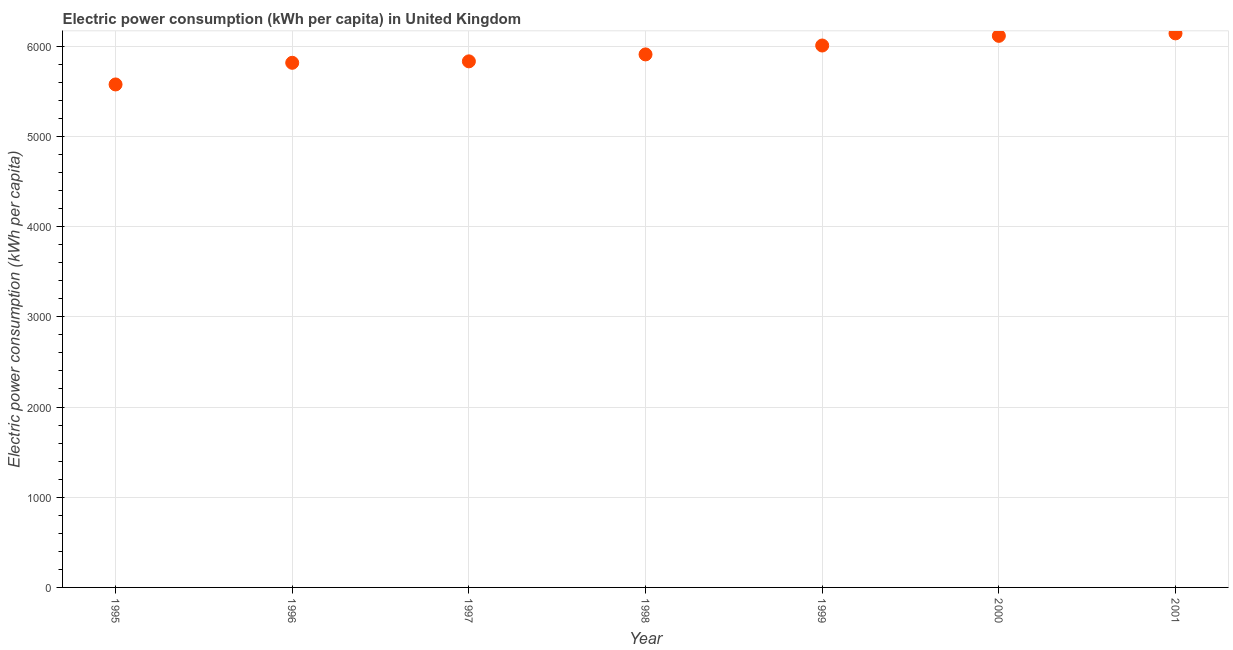What is the electric power consumption in 1996?
Keep it short and to the point. 5815.83. Across all years, what is the maximum electric power consumption?
Offer a terse response. 6141.98. Across all years, what is the minimum electric power consumption?
Provide a short and direct response. 5575.81. In which year was the electric power consumption minimum?
Give a very brief answer. 1995. What is the sum of the electric power consumption?
Your answer should be very brief. 4.14e+04. What is the difference between the electric power consumption in 1999 and 2001?
Make the answer very short. -134.5. What is the average electric power consumption per year?
Give a very brief answer. 5913.78. What is the median electric power consumption?
Give a very brief answer. 5908.87. Do a majority of the years between 2001 and 1996 (inclusive) have electric power consumption greater than 400 kWh per capita?
Provide a succinct answer. Yes. What is the ratio of the electric power consumption in 1995 to that in 2000?
Give a very brief answer. 0.91. Is the electric power consumption in 1996 less than that in 2000?
Your answer should be very brief. Yes. What is the difference between the highest and the second highest electric power consumption?
Offer a very short reply. 27.45. Is the sum of the electric power consumption in 1996 and 1999 greater than the maximum electric power consumption across all years?
Ensure brevity in your answer.  Yes. What is the difference between the highest and the lowest electric power consumption?
Your answer should be very brief. 566.17. What is the difference between two consecutive major ticks on the Y-axis?
Offer a very short reply. 1000. What is the title of the graph?
Keep it short and to the point. Electric power consumption (kWh per capita) in United Kingdom. What is the label or title of the X-axis?
Provide a short and direct response. Year. What is the label or title of the Y-axis?
Offer a terse response. Electric power consumption (kWh per capita). What is the Electric power consumption (kWh per capita) in 1995?
Your answer should be compact. 5575.81. What is the Electric power consumption (kWh per capita) in 1996?
Your answer should be compact. 5815.83. What is the Electric power consumption (kWh per capita) in 1997?
Provide a short and direct response. 5831.96. What is the Electric power consumption (kWh per capita) in 1998?
Your response must be concise. 5908.87. What is the Electric power consumption (kWh per capita) in 1999?
Your answer should be compact. 6007.48. What is the Electric power consumption (kWh per capita) in 2000?
Provide a short and direct response. 6114.53. What is the Electric power consumption (kWh per capita) in 2001?
Your answer should be very brief. 6141.98. What is the difference between the Electric power consumption (kWh per capita) in 1995 and 1996?
Offer a very short reply. -240.02. What is the difference between the Electric power consumption (kWh per capita) in 1995 and 1997?
Your response must be concise. -256.15. What is the difference between the Electric power consumption (kWh per capita) in 1995 and 1998?
Give a very brief answer. -333.06. What is the difference between the Electric power consumption (kWh per capita) in 1995 and 1999?
Make the answer very short. -431.68. What is the difference between the Electric power consumption (kWh per capita) in 1995 and 2000?
Provide a short and direct response. -538.72. What is the difference between the Electric power consumption (kWh per capita) in 1995 and 2001?
Make the answer very short. -566.17. What is the difference between the Electric power consumption (kWh per capita) in 1996 and 1997?
Your response must be concise. -16.13. What is the difference between the Electric power consumption (kWh per capita) in 1996 and 1998?
Keep it short and to the point. -93.04. What is the difference between the Electric power consumption (kWh per capita) in 1996 and 1999?
Ensure brevity in your answer.  -191.66. What is the difference between the Electric power consumption (kWh per capita) in 1996 and 2000?
Give a very brief answer. -298.7. What is the difference between the Electric power consumption (kWh per capita) in 1996 and 2001?
Your answer should be very brief. -326.15. What is the difference between the Electric power consumption (kWh per capita) in 1997 and 1998?
Your answer should be very brief. -76.91. What is the difference between the Electric power consumption (kWh per capita) in 1997 and 1999?
Offer a very short reply. -175.53. What is the difference between the Electric power consumption (kWh per capita) in 1997 and 2000?
Your answer should be compact. -282.57. What is the difference between the Electric power consumption (kWh per capita) in 1997 and 2001?
Your answer should be compact. -310.02. What is the difference between the Electric power consumption (kWh per capita) in 1998 and 1999?
Your answer should be very brief. -98.61. What is the difference between the Electric power consumption (kWh per capita) in 1998 and 2000?
Provide a short and direct response. -205.66. What is the difference between the Electric power consumption (kWh per capita) in 1998 and 2001?
Offer a terse response. -233.11. What is the difference between the Electric power consumption (kWh per capita) in 1999 and 2000?
Your answer should be compact. -107.04. What is the difference between the Electric power consumption (kWh per capita) in 1999 and 2001?
Offer a terse response. -134.5. What is the difference between the Electric power consumption (kWh per capita) in 2000 and 2001?
Ensure brevity in your answer.  -27.45. What is the ratio of the Electric power consumption (kWh per capita) in 1995 to that in 1996?
Keep it short and to the point. 0.96. What is the ratio of the Electric power consumption (kWh per capita) in 1995 to that in 1997?
Your answer should be compact. 0.96. What is the ratio of the Electric power consumption (kWh per capita) in 1995 to that in 1998?
Ensure brevity in your answer.  0.94. What is the ratio of the Electric power consumption (kWh per capita) in 1995 to that in 1999?
Offer a very short reply. 0.93. What is the ratio of the Electric power consumption (kWh per capita) in 1995 to that in 2000?
Offer a very short reply. 0.91. What is the ratio of the Electric power consumption (kWh per capita) in 1995 to that in 2001?
Provide a succinct answer. 0.91. What is the ratio of the Electric power consumption (kWh per capita) in 1996 to that in 1997?
Your answer should be compact. 1. What is the ratio of the Electric power consumption (kWh per capita) in 1996 to that in 1998?
Your response must be concise. 0.98. What is the ratio of the Electric power consumption (kWh per capita) in 1996 to that in 2000?
Provide a succinct answer. 0.95. What is the ratio of the Electric power consumption (kWh per capita) in 1996 to that in 2001?
Offer a terse response. 0.95. What is the ratio of the Electric power consumption (kWh per capita) in 1997 to that in 1998?
Give a very brief answer. 0.99. What is the ratio of the Electric power consumption (kWh per capita) in 1997 to that in 1999?
Give a very brief answer. 0.97. What is the ratio of the Electric power consumption (kWh per capita) in 1997 to that in 2000?
Your response must be concise. 0.95. What is the ratio of the Electric power consumption (kWh per capita) in 1998 to that in 2000?
Your answer should be very brief. 0.97. What is the ratio of the Electric power consumption (kWh per capita) in 1999 to that in 2000?
Your answer should be compact. 0.98. What is the ratio of the Electric power consumption (kWh per capita) in 1999 to that in 2001?
Provide a succinct answer. 0.98. What is the ratio of the Electric power consumption (kWh per capita) in 2000 to that in 2001?
Offer a terse response. 1. 